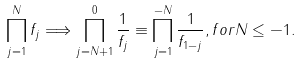<formula> <loc_0><loc_0><loc_500><loc_500>\prod _ { j = 1 } ^ { N } f _ { j } \Longrightarrow \prod _ { j = N + 1 } ^ { 0 } \frac { 1 } { f _ { j } } \equiv \prod _ { j = 1 } ^ { - N } \frac { 1 } { f _ { 1 - j } } , f o r N \leq - 1 .</formula> 